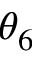<formula> <loc_0><loc_0><loc_500><loc_500>\theta _ { 6 }</formula> 